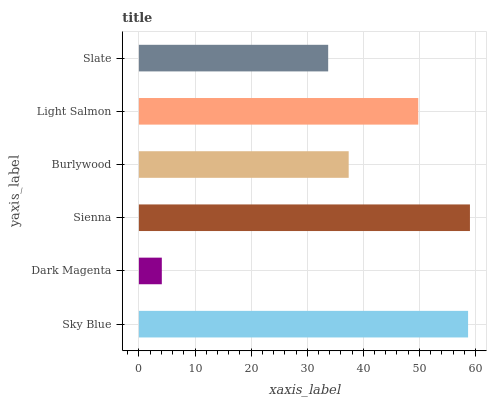Is Dark Magenta the minimum?
Answer yes or no. Yes. Is Sienna the maximum?
Answer yes or no. Yes. Is Sienna the minimum?
Answer yes or no. No. Is Dark Magenta the maximum?
Answer yes or no. No. Is Sienna greater than Dark Magenta?
Answer yes or no. Yes. Is Dark Magenta less than Sienna?
Answer yes or no. Yes. Is Dark Magenta greater than Sienna?
Answer yes or no. No. Is Sienna less than Dark Magenta?
Answer yes or no. No. Is Light Salmon the high median?
Answer yes or no. Yes. Is Burlywood the low median?
Answer yes or no. Yes. Is Burlywood the high median?
Answer yes or no. No. Is Slate the low median?
Answer yes or no. No. 